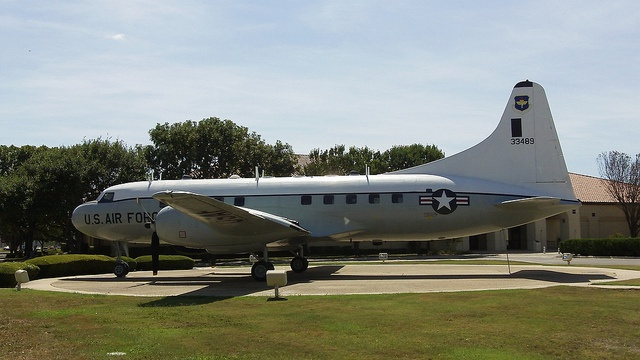Describe the objects in this image and their specific colors. I can see a airplane in lightgray, black, and gray tones in this image. 